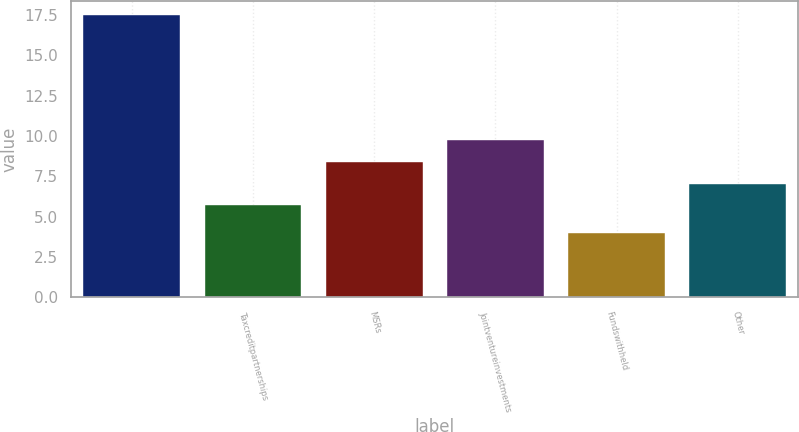Convert chart. <chart><loc_0><loc_0><loc_500><loc_500><bar_chart><ecel><fcel>Taxcreditpartnerships<fcel>MSRs<fcel>Jointventureinvestments<fcel>Fundswithheld<fcel>Other<nl><fcel>17.5<fcel>5.7<fcel>8.4<fcel>9.75<fcel>4<fcel>7.05<nl></chart> 